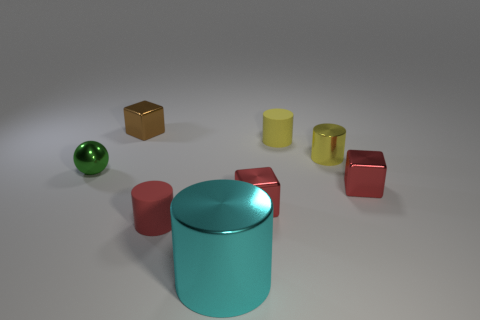There is a cyan object in front of the yellow rubber cylinder; is there a red rubber cylinder that is in front of it? no 